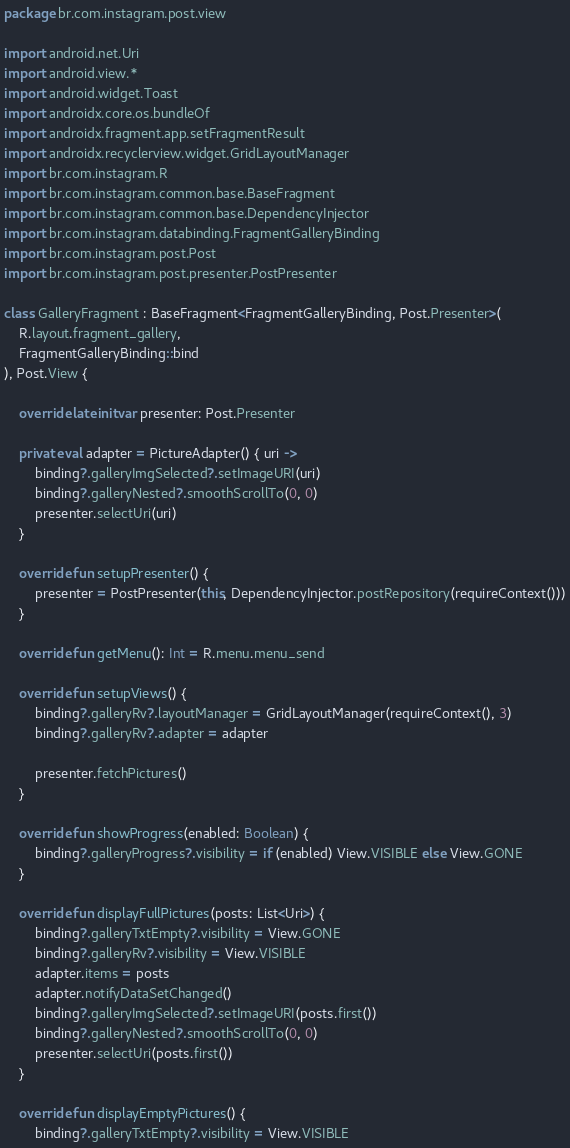<code> <loc_0><loc_0><loc_500><loc_500><_Kotlin_>package br.com.instagram.post.view

import android.net.Uri
import android.view.*
import android.widget.Toast
import androidx.core.os.bundleOf
import androidx.fragment.app.setFragmentResult
import androidx.recyclerview.widget.GridLayoutManager
import br.com.instagram.R
import br.com.instagram.common.base.BaseFragment
import br.com.instagram.common.base.DependencyInjector
import br.com.instagram.databinding.FragmentGalleryBinding
import br.com.instagram.post.Post
import br.com.instagram.post.presenter.PostPresenter

class GalleryFragment : BaseFragment<FragmentGalleryBinding, Post.Presenter>(
    R.layout.fragment_gallery,
    FragmentGalleryBinding::bind
), Post.View {

    override lateinit var presenter: Post.Presenter

    private val adapter = PictureAdapter() { uri ->
        binding?.galleryImgSelected?.setImageURI(uri)
        binding?.galleryNested?.smoothScrollTo(0, 0)
        presenter.selectUri(uri)
    }

    override fun setupPresenter() {
        presenter = PostPresenter(this, DependencyInjector.postRepository(requireContext()))
    }

    override fun getMenu(): Int = R.menu.menu_send

    override fun setupViews() {
        binding?.galleryRv?.layoutManager = GridLayoutManager(requireContext(), 3)
        binding?.galleryRv?.adapter = adapter

        presenter.fetchPictures()
    }

    override fun showProgress(enabled: Boolean) {
        binding?.galleryProgress?.visibility = if (enabled) View.VISIBLE else View.GONE
    }

    override fun displayFullPictures(posts: List<Uri>) {
        binding?.galleryTxtEmpty?.visibility = View.GONE
        binding?.galleryRv?.visibility = View.VISIBLE
        adapter.items = posts
        adapter.notifyDataSetChanged()
        binding?.galleryImgSelected?.setImageURI(posts.first())
        binding?.galleryNested?.smoothScrollTo(0, 0)
        presenter.selectUri(posts.first())
    }

    override fun displayEmptyPictures() {
        binding?.galleryTxtEmpty?.visibility = View.VISIBLE</code> 